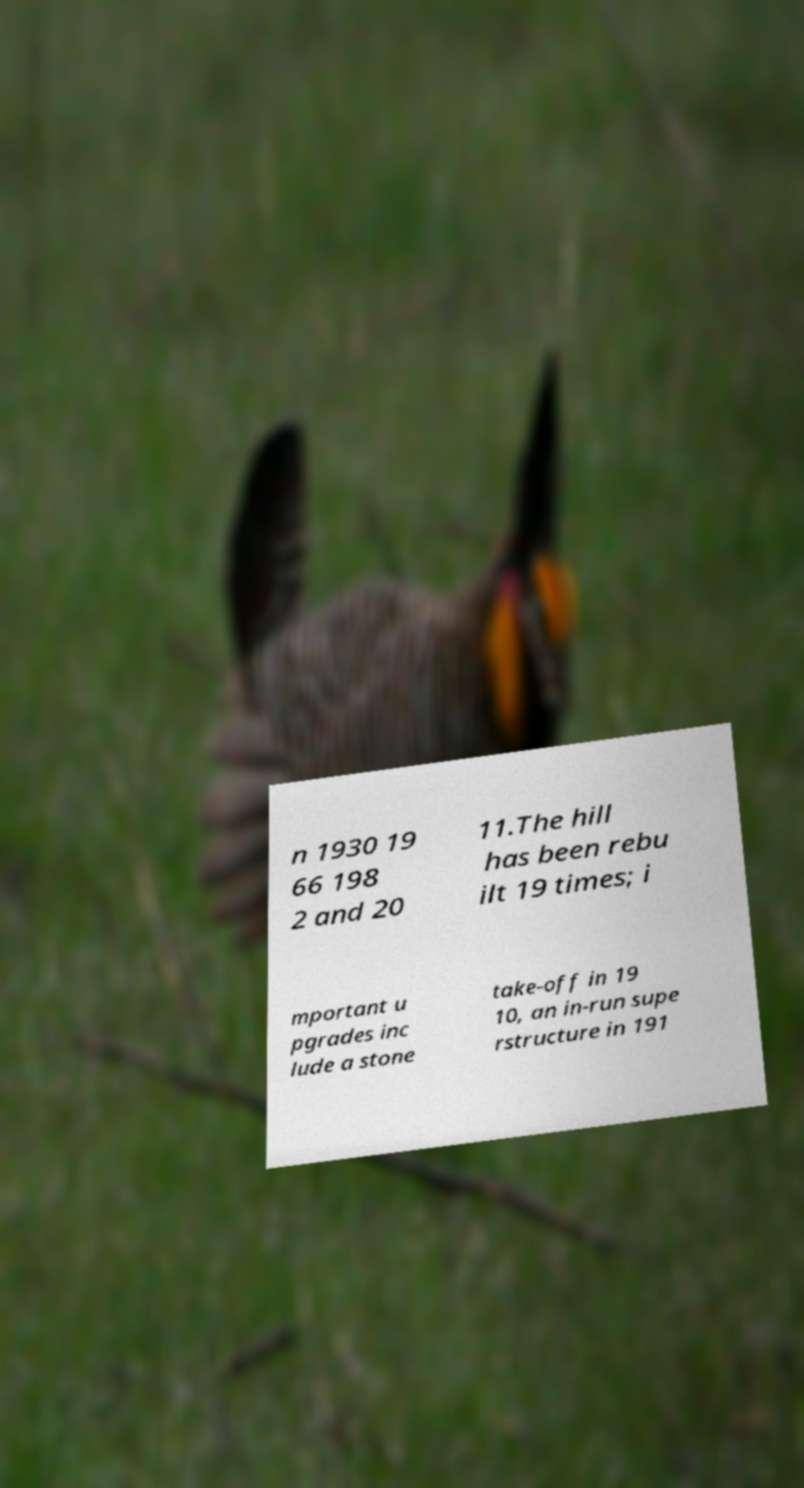There's text embedded in this image that I need extracted. Can you transcribe it verbatim? n 1930 19 66 198 2 and 20 11.The hill has been rebu ilt 19 times; i mportant u pgrades inc lude a stone take-off in 19 10, an in-run supe rstructure in 191 